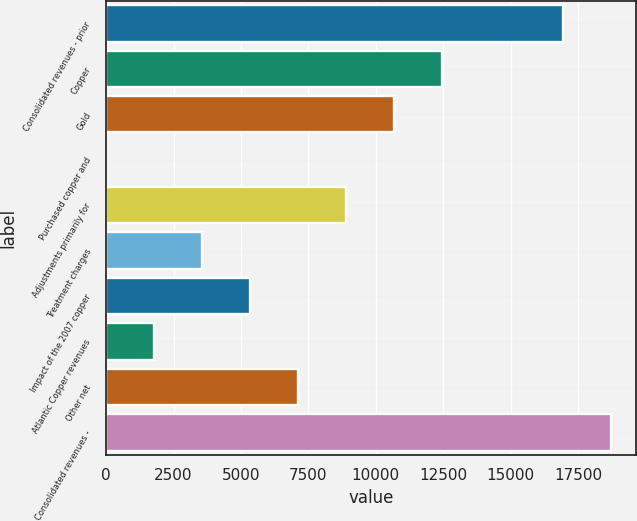Convert chart to OTSL. <chart><loc_0><loc_0><loc_500><loc_500><bar_chart><fcel>Consolidated revenues - prior<fcel>Copper<fcel>Gold<fcel>Purchased copper and<fcel>Adjustments primarily for<fcel>Treatment charges<fcel>Impact of the 2007 copper<fcel>Atlantic Copper revenues<fcel>Other net<fcel>Consolidated revenues -<nl><fcel>16939<fcel>12458.7<fcel>10679.6<fcel>5<fcel>8900.5<fcel>3563.2<fcel>5342.3<fcel>1784.1<fcel>7121.4<fcel>18718.1<nl></chart> 